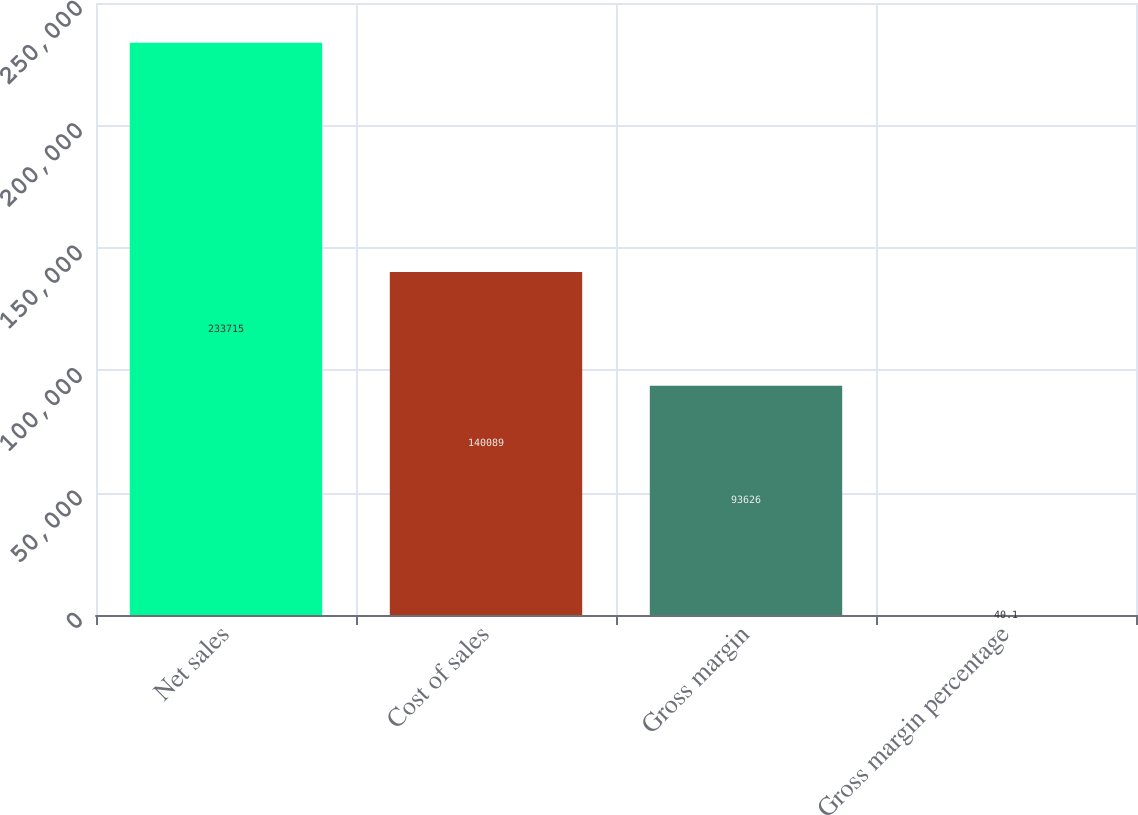Convert chart. <chart><loc_0><loc_0><loc_500><loc_500><bar_chart><fcel>Net sales<fcel>Cost of sales<fcel>Gross margin<fcel>Gross margin percentage<nl><fcel>233715<fcel>140089<fcel>93626<fcel>40.1<nl></chart> 